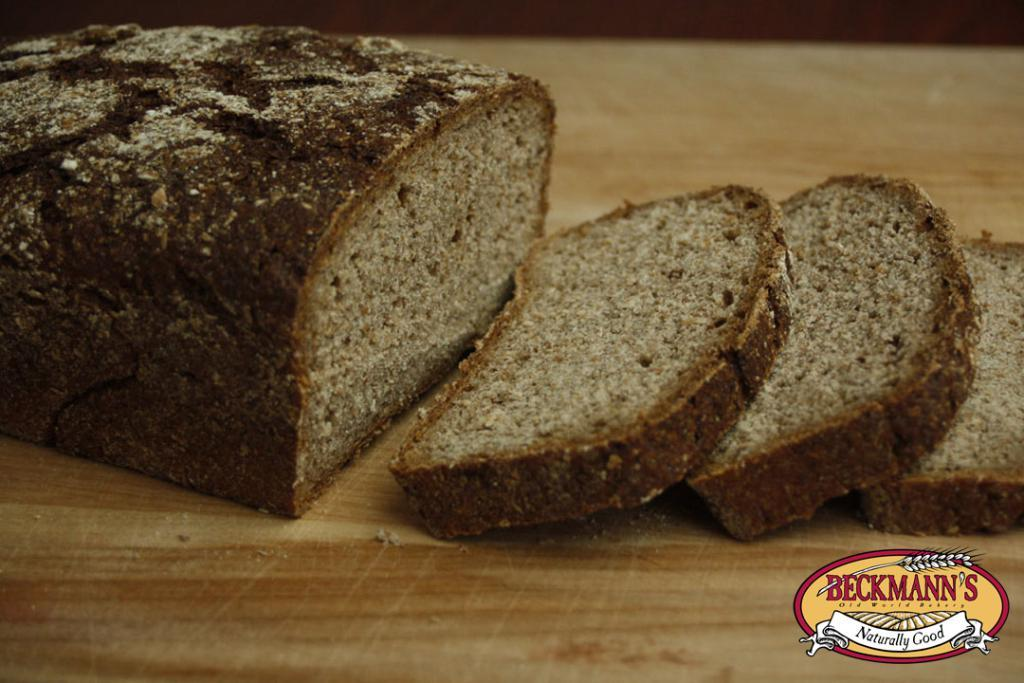What type of bread is shown in the image? There is chocolate bread in the image. How is the chocolate bread presented? The chocolate bread is in pieces. Where are the chocolate bread and pieces located? They are on a table. Is there any additional information visible in the image? Yes, there is a watermark in the bottom right corner of the image. What type of zinc is present in the image? There is no zinc present in the image. Can you tell me the credit limit of the person in the image? There is no person in the image, and therefore no credit limit can be determined. 